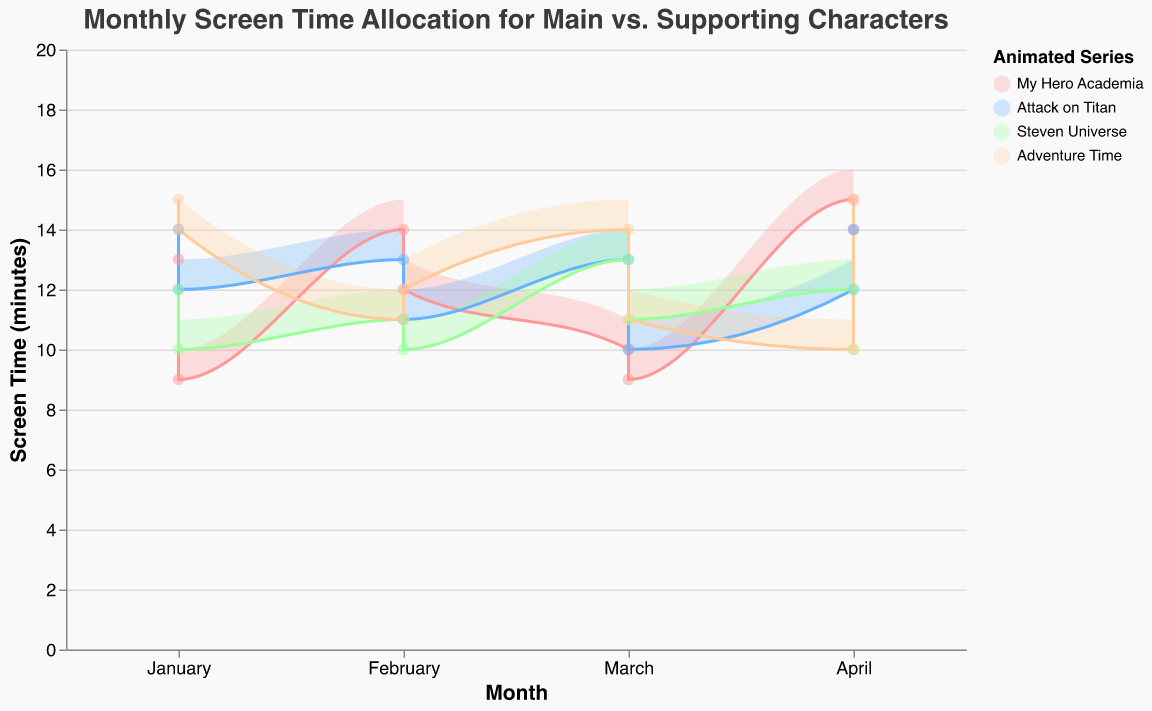What's the title of the figure? The title is usually located at the top of the figure. In this figure, the title reads "Monthly Screen Time Allocation for Main vs. Supporting Characters".
Answer: Monthly Screen Time Allocation for Main vs. Supporting Characters Which series has the highest screen time for main characters in March? In March, "Adventure Time" has the highest screen time for main characters at 14-15 minutes. This can be identified by looking for the March data points and comparing the heights of the lines for each series.
Answer: Adventure Time How many series are compared in the chart? The legend on the right side of the chart displays the names of all series compared. There are four series: "My Hero Academia", "Attack on Titan", "Steven Universe", and "Adventure Time".
Answer: Four What's the color used to represent "Attack on Titan"? The color for "Attack on Titan" can be found in the legend. It is represented by a blue color.
Answer: Blue What is the range of screen time for supporting characters in "My Hero Academia" for January? For January, "My Hero Academia" shows supporting character screen time ranging from 6 to 7 minutes. This is indicated by the shaded area and specific data points for that month.
Answer: 6-7 minutes Which month shows the highest variation in screen time for main characters in "Steven Universe"? April displays a wider area for "Steven Universe", ranging from 10 to 12 minutes, which suggests the highest variation compared to other months.
Answer: April What's the average maximum screen time for main characters across all series in February? For February, sum the maximum screen times for each series, and then divide by the number of series. Main characters in "My Hero Academia" (15), "Attack on Titan" (14), "Steven Universe" (12), "Adventure Time" (13) sum up to 54. Average is 54/4 = 13.5.
Answer: 13.5 minutes Compare the screen time for main characters of "My Hero Academia" and "Attack on Titan" in April. Which has more? In April, "My Hero Academia" main characters have a screen time range of 14-16 minutes, whereas "Attack on Titan" has a range of 14-15 minutes. The maximum screen time is higher for "My Hero Academia".
Answer: My Hero Academia What's the median minimum screen time for supporting characters in "Adventure Time"? To calculate the median, list the minimum screen times of "Adventure Time" for each month (8, 7, 4, 5, 6, 5, 7, 8), and find the middle value. The sorted list is (4, 5, 5, 6, 7, 7, 8, 8). The median is the average of the two middle values (6+7)/2 = 6.5.
Answer: 6.5 minutes Which series had the least variation in screen time for main characters in January? In January, "Steven Universe" had the least variation with screen time just 12-13 minutes. This is indicated by a smaller shaded area compared to other series.
Answer: Steven Universe 